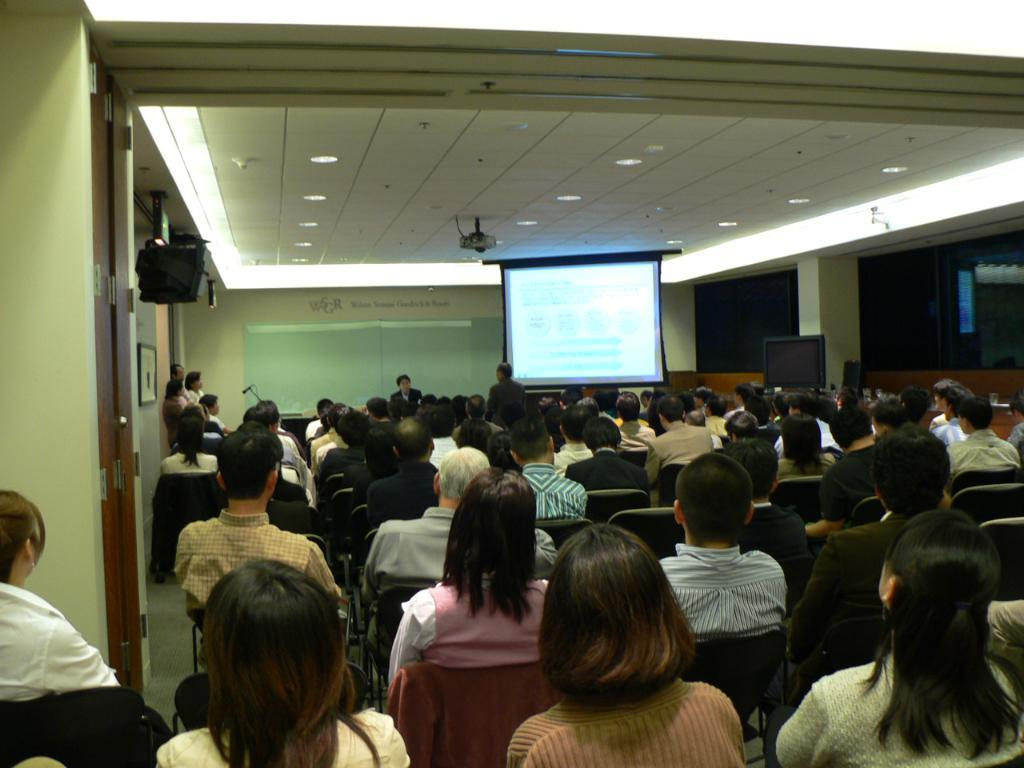What are the people in the image doing? The people in the image are sitting on chairs. What can be seen on the wall or surface in the image? There is a screen in the image. What architectural feature is present in the image? There is a door in the image. What is on the roof in the image? There are lights on the roof in the image. What type of cloth is being used to sing a song in the image? There is no cloth or singing present in the image. 